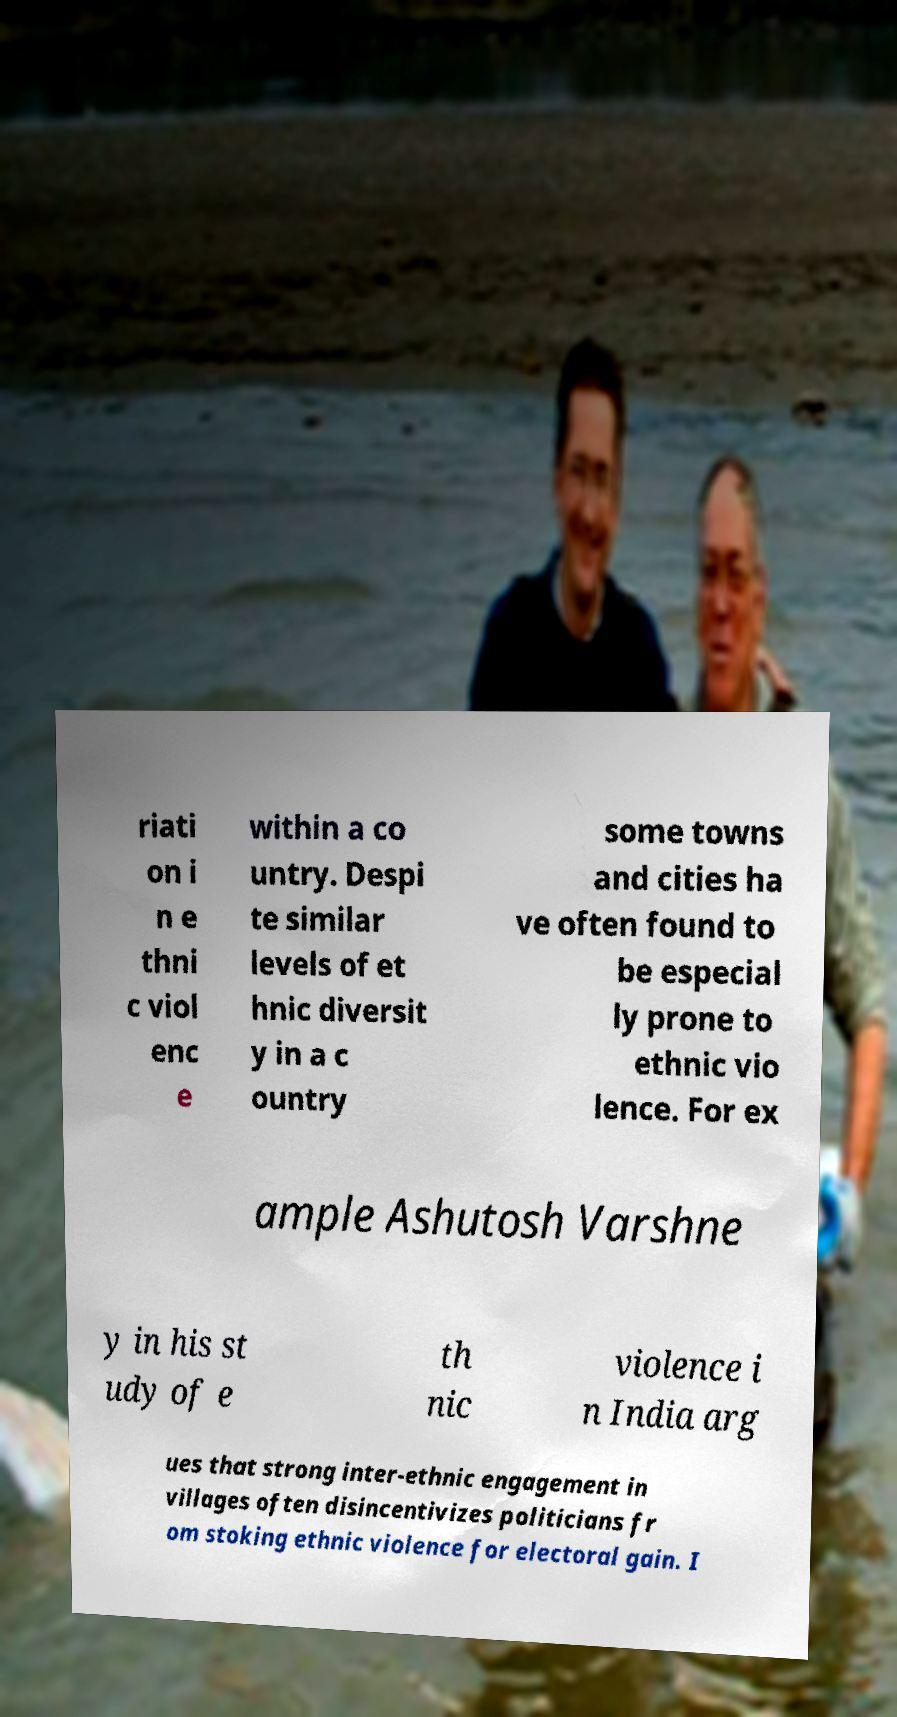Can you accurately transcribe the text from the provided image for me? riati on i n e thni c viol enc e within a co untry. Despi te similar levels of et hnic diversit y in a c ountry some towns and cities ha ve often found to be especial ly prone to ethnic vio lence. For ex ample Ashutosh Varshne y in his st udy of e th nic violence i n India arg ues that strong inter-ethnic engagement in villages often disincentivizes politicians fr om stoking ethnic violence for electoral gain. I 